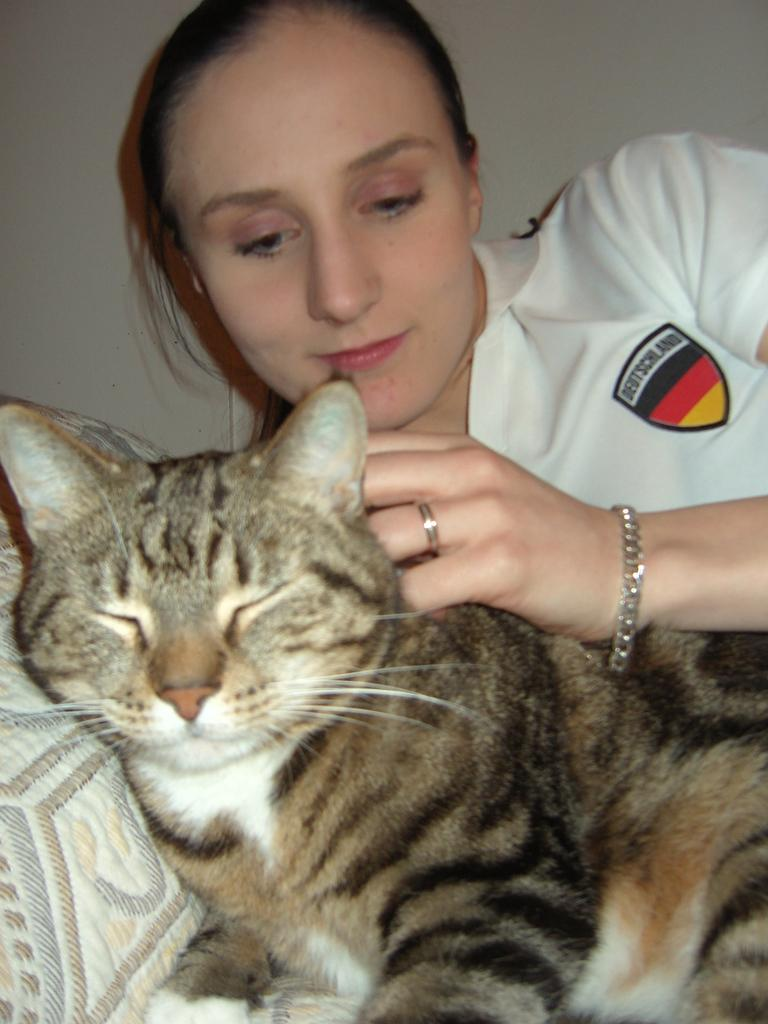What animal is lying on a cloth in the image? There is a cat lying on a cloth in the image. Who is present in the image besides the cat? There is a woman in the image. What can be seen in the background of the image? There is a wall in the background of the image. What type of oven can be seen in the image? There is no oven present in the image. How many ants are crawling on the cat in the image? There are no ants present in the image; the cat is lying on a cloth. 